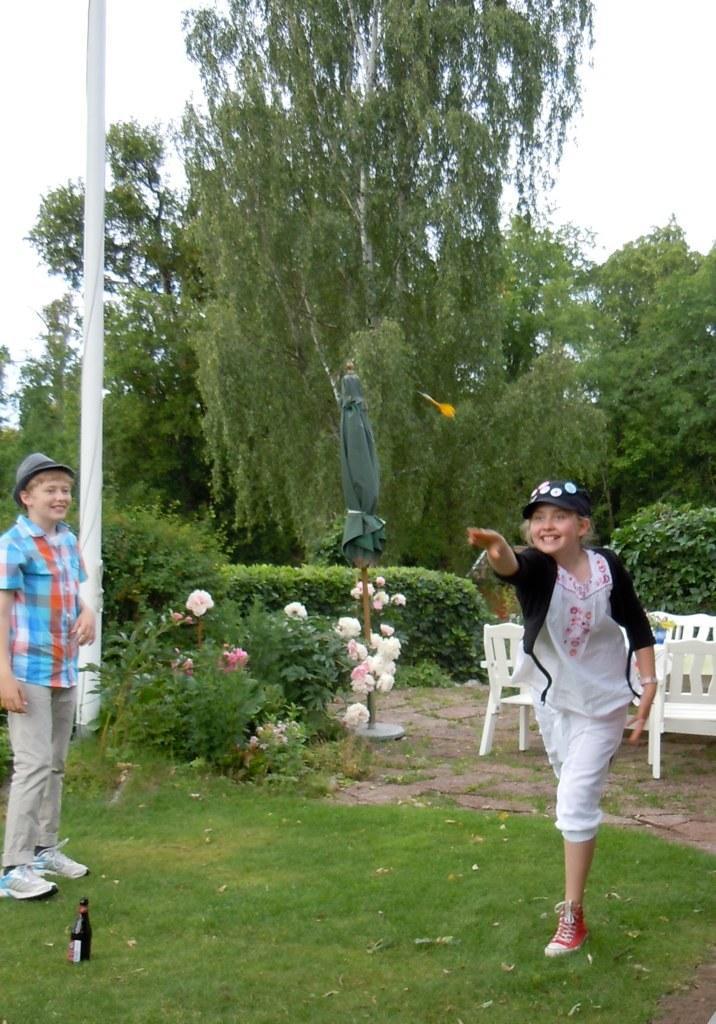Could you give a brief overview of what you see in this image? In this image I can see a two children's. Back Side I can see white chairs and trees. We can see bottle and umbrella. I can see a pole. The sky is in white color. 